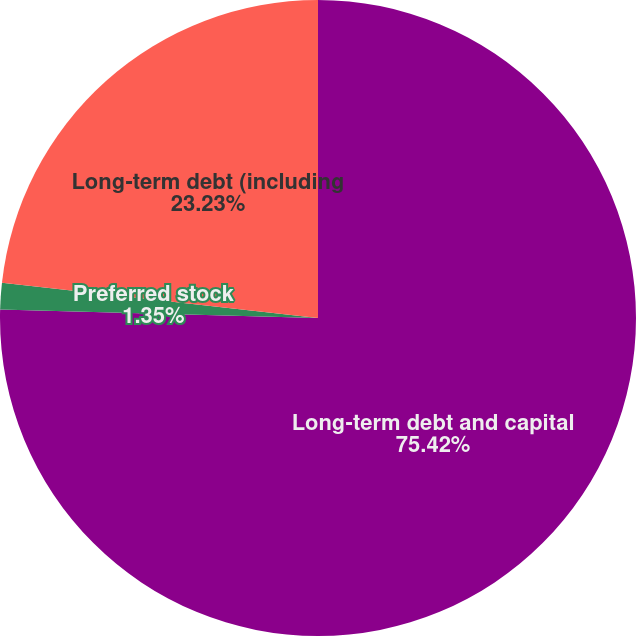Convert chart to OTSL. <chart><loc_0><loc_0><loc_500><loc_500><pie_chart><fcel>Long-term debt and capital<fcel>Preferred stock<fcel>Long-term debt (including<nl><fcel>75.42%<fcel>1.35%<fcel>23.23%<nl></chart> 